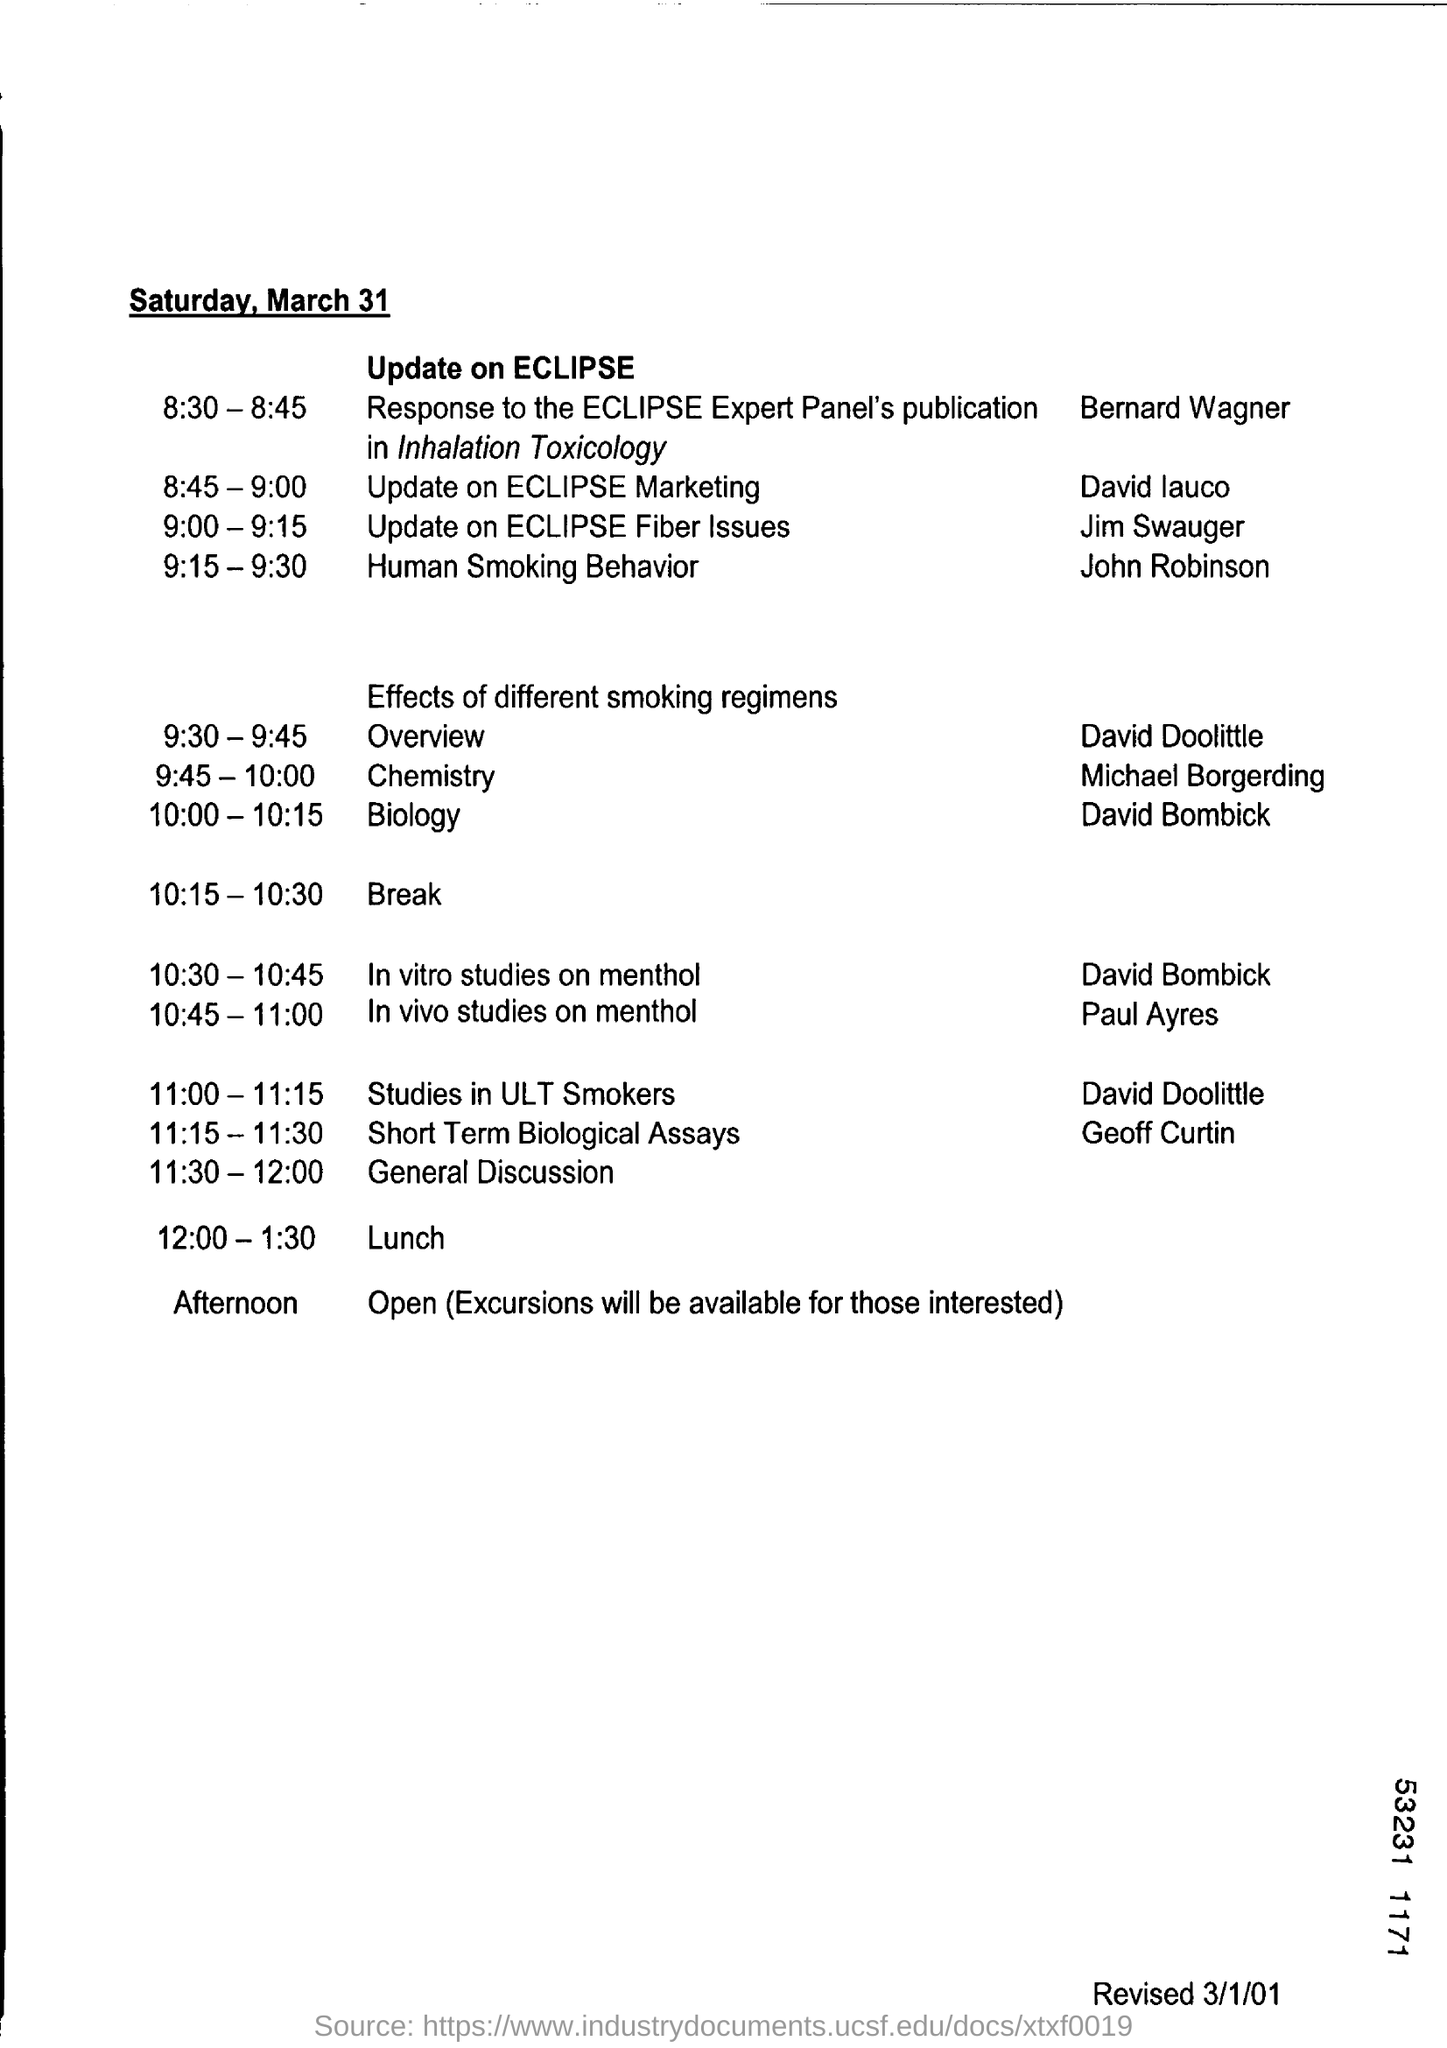Identify some key points in this picture. The event headed by Paul Ayres from 10:45-11:00 is the in vivo study on menthol. David Bombick is a participant in in vitro studies on menthol. At 9:00-9:15, there will be an event to provide an update on the ECLIPSE Fiber issues. 